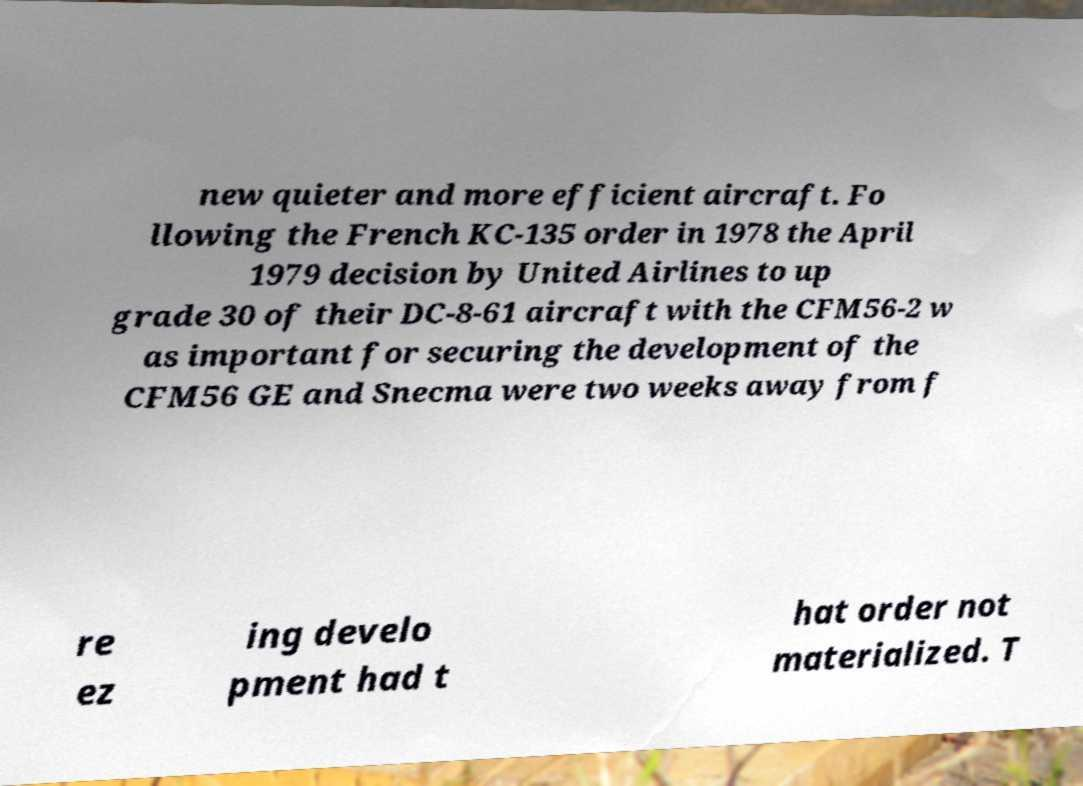For documentation purposes, I need the text within this image transcribed. Could you provide that? new quieter and more efficient aircraft. Fo llowing the French KC-135 order in 1978 the April 1979 decision by United Airlines to up grade 30 of their DC-8-61 aircraft with the CFM56-2 w as important for securing the development of the CFM56 GE and Snecma were two weeks away from f re ez ing develo pment had t hat order not materialized. T 